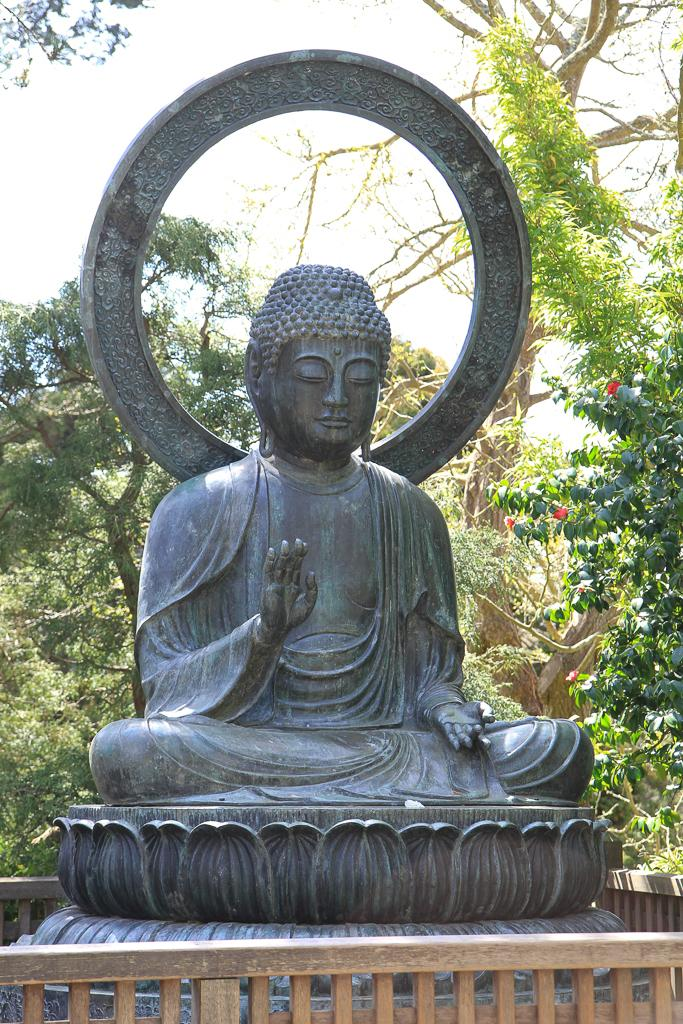What is the main subject in the image? There is a statue in the image. What type of natural elements can be seen in the image? There are trees and flowers in the image. What type of structure is present in the image? There is a fence in the image. What can be seen in the background of the image? The sky is visible in the background of the image. What type of jam is being spread on the statue in the image? There is no jam present in the image, and the statue is not being used for spreading jam. 